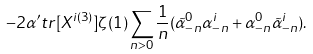Convert formula to latex. <formula><loc_0><loc_0><loc_500><loc_500>- 2 \alpha ^ { \prime } t r [ X ^ { i ( 3 ) } ] \zeta ( 1 ) \sum _ { n > 0 } \frac { 1 } { n } ( \tilde { \alpha } ^ { 0 } _ { - n } \alpha ^ { i } _ { - n } + \alpha ^ { 0 } _ { - n } \tilde { \alpha } ^ { i } _ { - n } ) .</formula> 